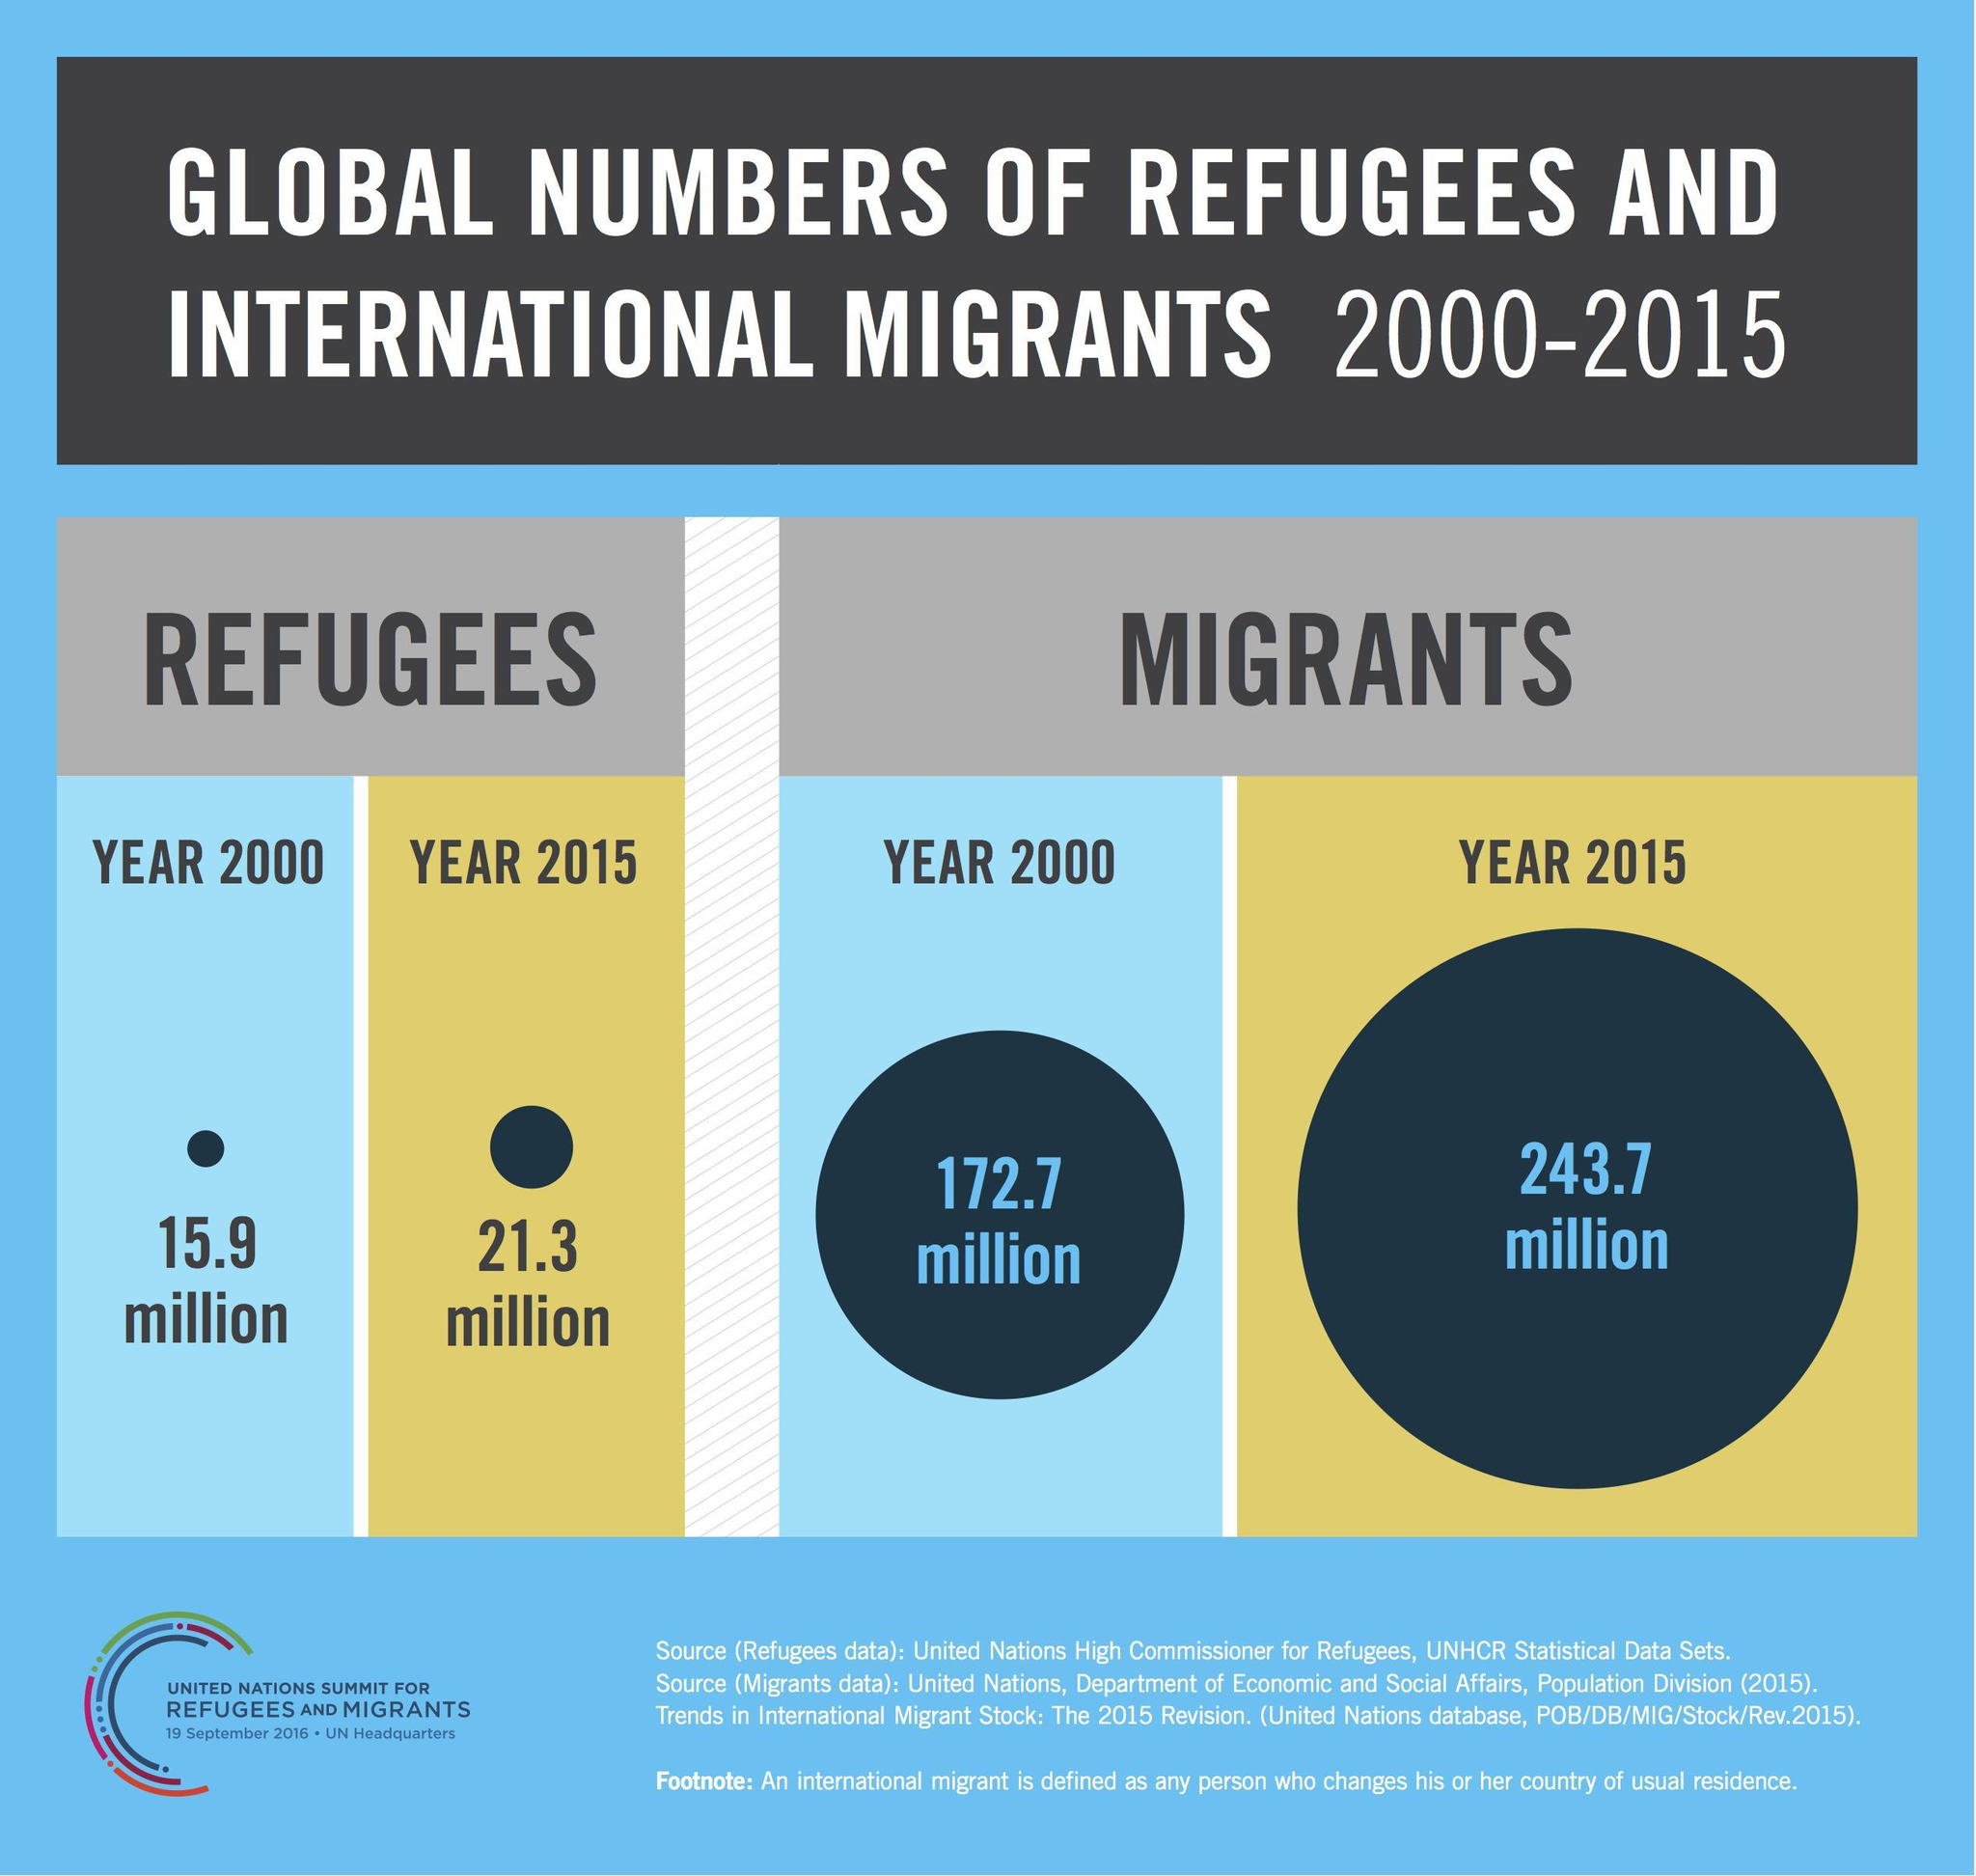What is the increase in number of refugees in the year 2015 from the year 2000?
Answer the question with a short phrase. 5.4 million What is the increase in the number of migrants in the year 2015 in comparison with the year 2000? 71 million 